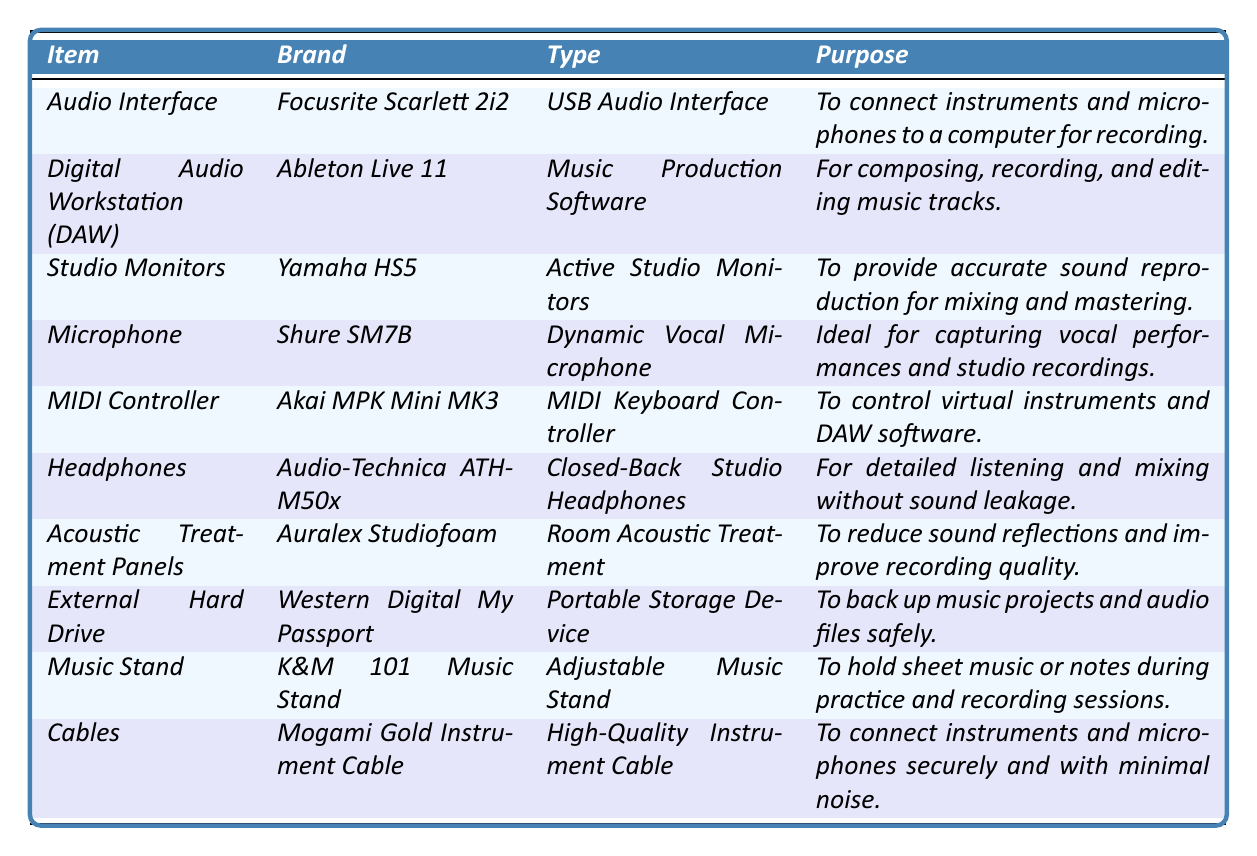What is the brand of the MIDI Controller? The table shows that the brand associated with the MIDI Controller is Akai MPK Mini MK3.
Answer: Akai MPK Mini MK3 What is the purpose of the Audio Interface? The purpose of the Audio Interface, which is the Focusrite Scarlett 2i2, is to connect instruments and microphones to a computer for recording.
Answer: To connect instruments and microphones to a computer for recording Which item is used to improve recording quality? The Acoustic Treatment Panels (Auralex Studiofoam) are specifically listed in the table as the item used to reduce sound reflections and improve recording quality.
Answer: Acoustic Treatment Panels How many items listed are dedicated to sound reproduction? The items related to sound reproduction are the Studio Monitors and Headphones, totaling 2 items.
Answer: 2 items Is the Shure SM7B microphone a dynamic or condenser microphone? According to the table, the Shure SM7B is labeled as a Dynamic Vocal Microphone, not a condenser.
Answer: Dynamic What are the two purpose categories for the gear listed in the inventory? The equipment can be categorized into two purposes: for recording (like Audio Interface, Microphone) and for post-production (like Studio Monitors, DAW).
Answer: Recording and post-production Which equipment type is used to control virtual instruments? The table indicates that the MIDI Controller is utilized specifically for controlling virtual instruments and DAW software.
Answer: MIDI Controller If you need to back up music projects, which item should you use? The External Hard Drive (Western Digital My Passport) is designed for backing up music projects and audio files safely.
Answer: External Hard Drive Do all items in the inventory serve the same purpose? No, the items are for various purposes including recording, sound reproduction, and acoustic treatment.
Answer: No How many different brands are listed in the equipment inventory? The brands listed in the inventory are Focusrite, Ableton, Yamaha, Shure, Akai, Audio-Technica, Auralex, Western Digital, and K&M, totaling 9 brands.
Answer: 9 brands 